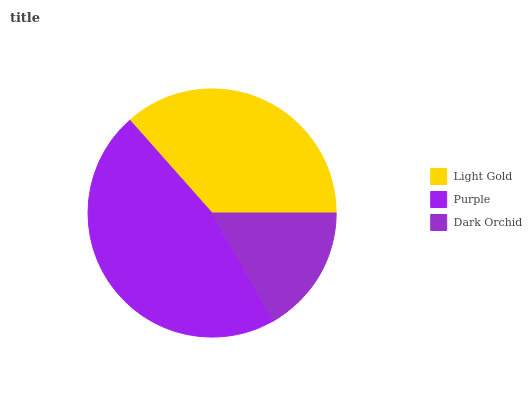Is Dark Orchid the minimum?
Answer yes or no. Yes. Is Purple the maximum?
Answer yes or no. Yes. Is Purple the minimum?
Answer yes or no. No. Is Dark Orchid the maximum?
Answer yes or no. No. Is Purple greater than Dark Orchid?
Answer yes or no. Yes. Is Dark Orchid less than Purple?
Answer yes or no. Yes. Is Dark Orchid greater than Purple?
Answer yes or no. No. Is Purple less than Dark Orchid?
Answer yes or no. No. Is Light Gold the high median?
Answer yes or no. Yes. Is Light Gold the low median?
Answer yes or no. Yes. Is Purple the high median?
Answer yes or no. No. Is Dark Orchid the low median?
Answer yes or no. No. 